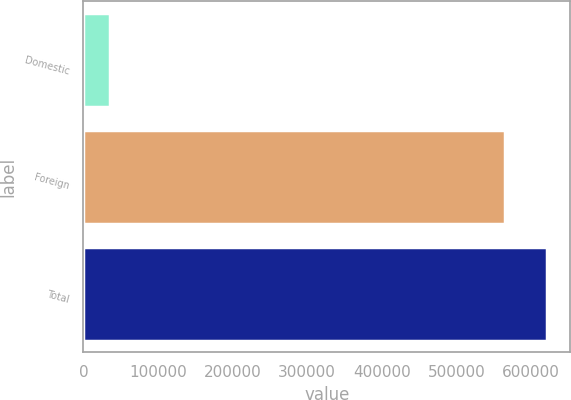Convert chart to OTSL. <chart><loc_0><loc_0><loc_500><loc_500><bar_chart><fcel>Domestic<fcel>Foreign<fcel>Total<nl><fcel>35154<fcel>564960<fcel>621456<nl></chart> 